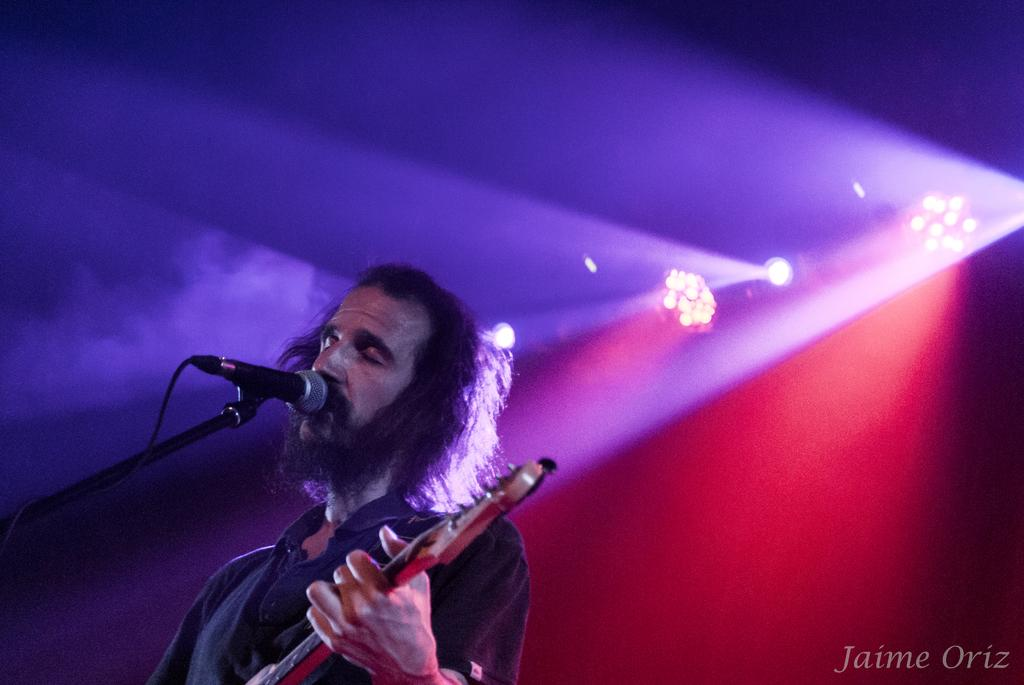What is the person in the image holding? The person is holding a musical instrument in the image. What device is present for amplifying sound? There is a microphone (mic) in the image. What object is used to support or hold something in the image? There is a stand in the image. What type of lighting is visible in the image? There are colorful lights visible in the image. What type of vacation is the person planning based on the image? There is no information about a vacation in the image; it only shows a person holding a musical instrument, a microphone, a stand, and colorful lights. 